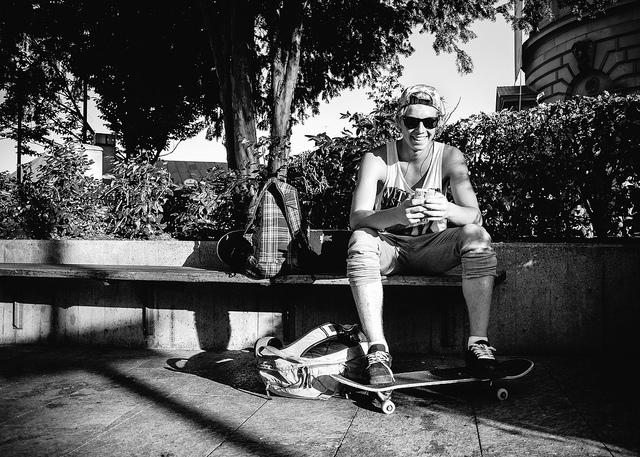What's the man taking a break from? Please explain your reasoning. skateboarding. The man is sitting with his skateboard on a bench and taking a break., 